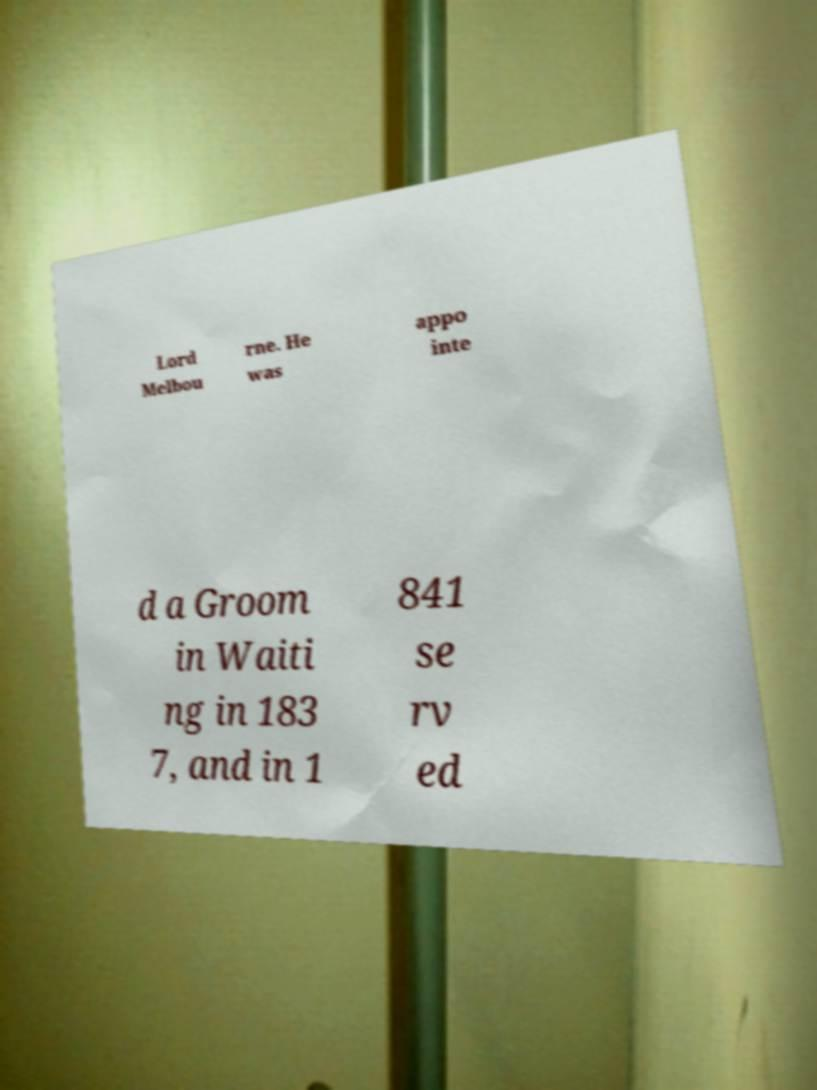I need the written content from this picture converted into text. Can you do that? Lord Melbou rne. He was appo inte d a Groom in Waiti ng in 183 7, and in 1 841 se rv ed 